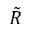<formula> <loc_0><loc_0><loc_500><loc_500>\tilde { R }</formula> 